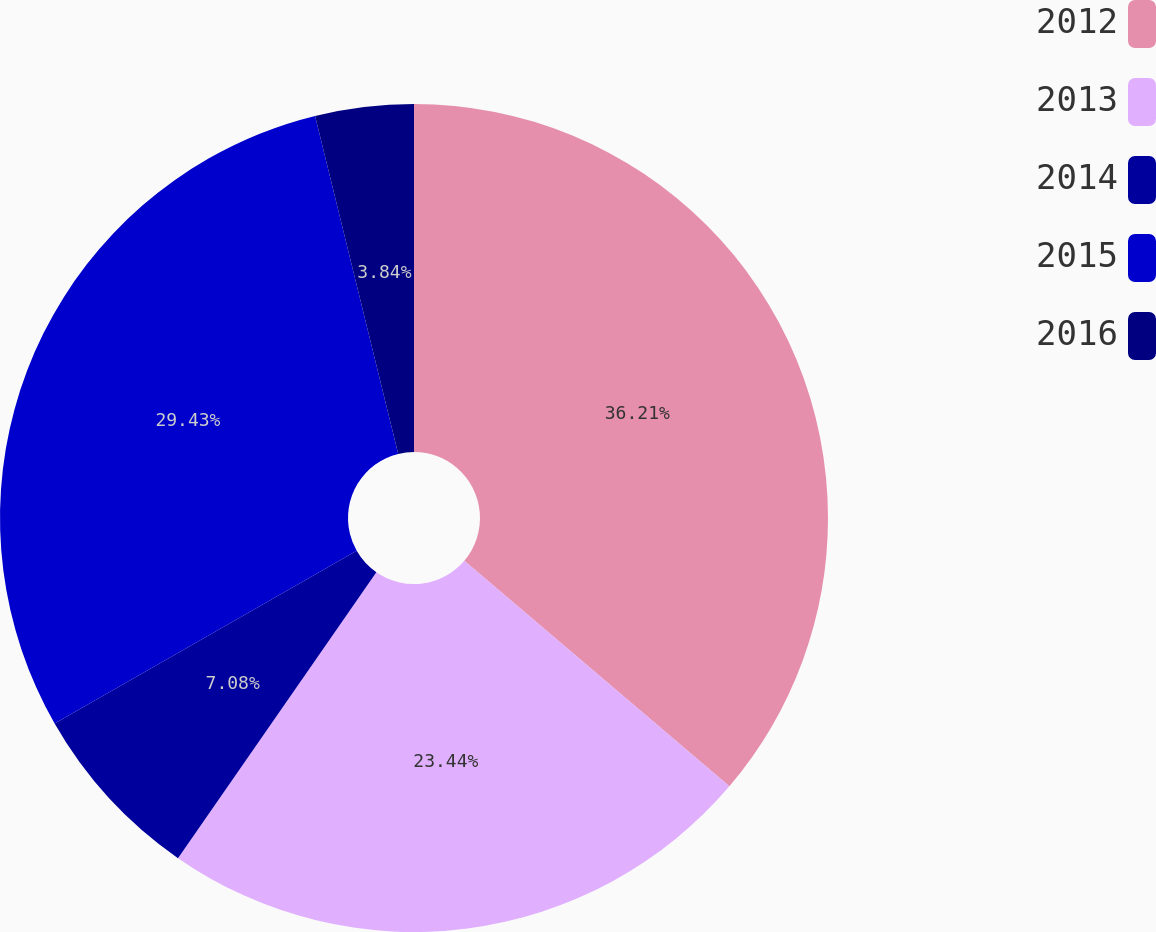<chart> <loc_0><loc_0><loc_500><loc_500><pie_chart><fcel>2012<fcel>2013<fcel>2014<fcel>2015<fcel>2016<nl><fcel>36.22%<fcel>23.44%<fcel>7.08%<fcel>29.43%<fcel>3.84%<nl></chart> 